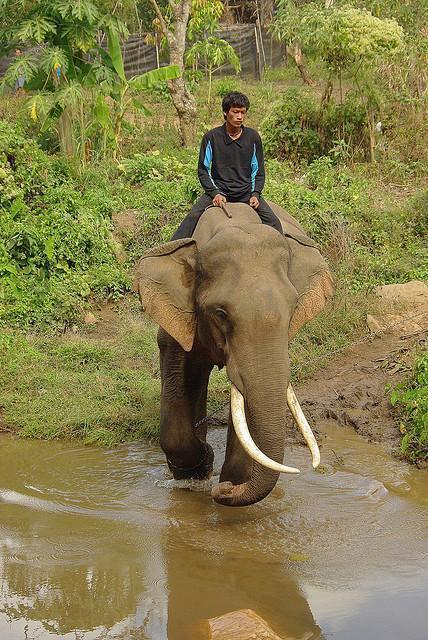Is the statement "The elephant is under the person." accurate regarding the image?
Answer yes or no. Yes. 